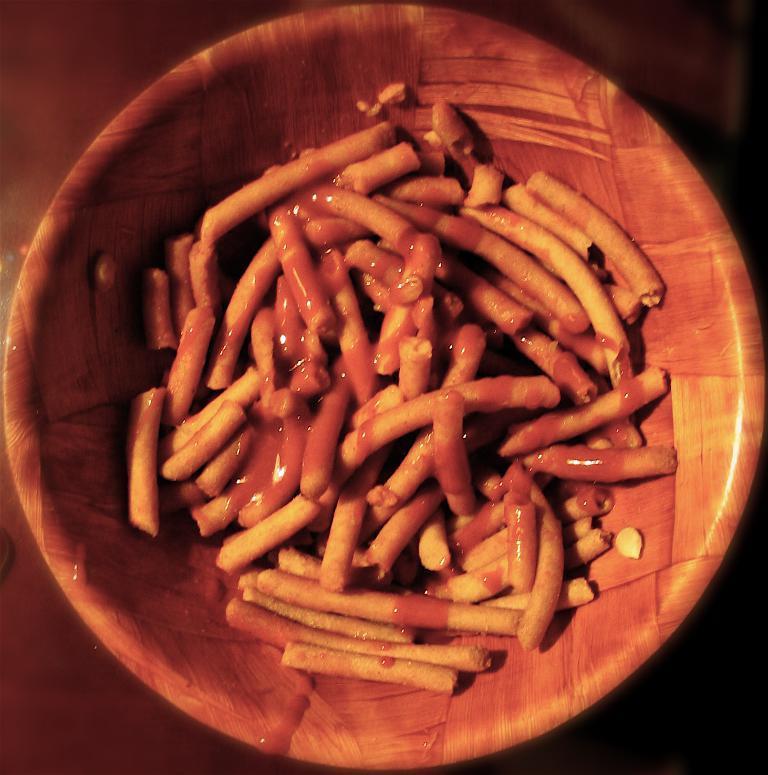In one or two sentences, can you explain what this image depicts? Here I can see a bowl which consists of some food item. This bowl is placed on a wooden surface. 